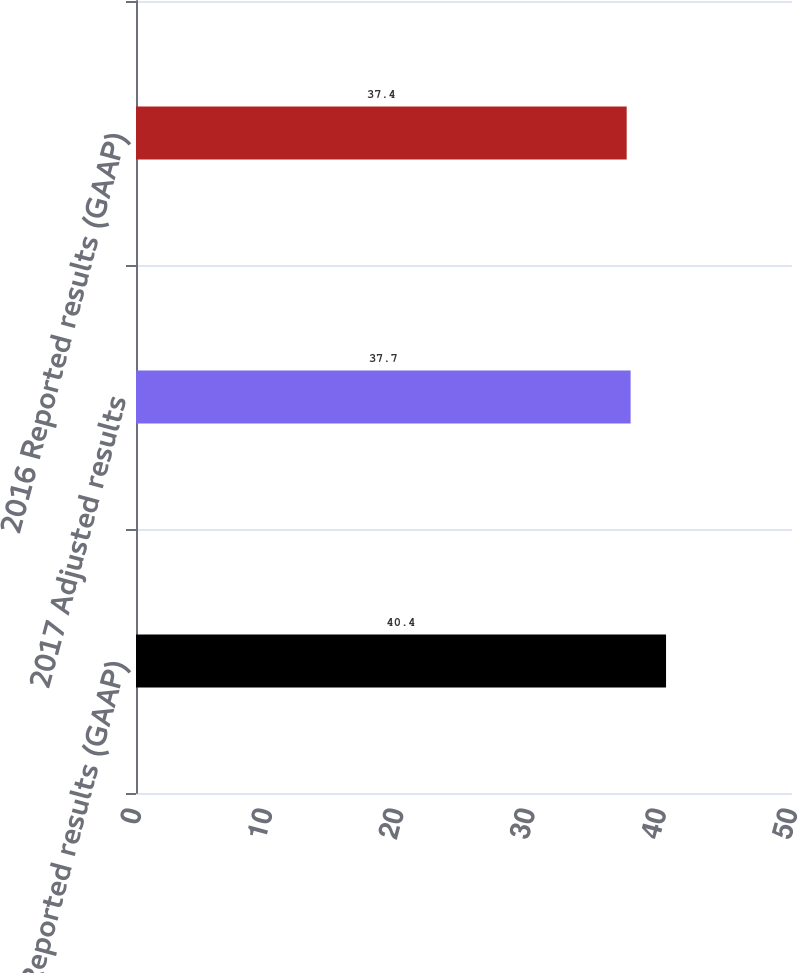<chart> <loc_0><loc_0><loc_500><loc_500><bar_chart><fcel>2017 Reported results (GAAP)<fcel>2017 Adjusted results<fcel>2016 Reported results (GAAP)<nl><fcel>40.4<fcel>37.7<fcel>37.4<nl></chart> 